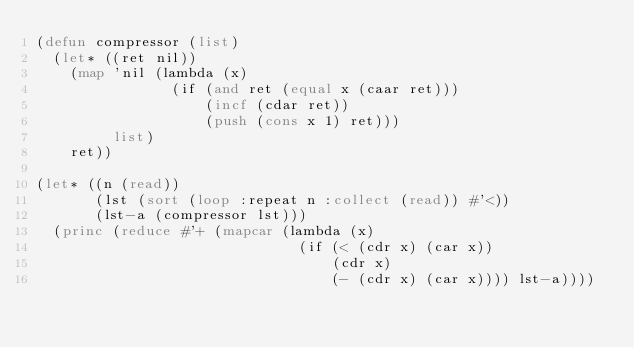<code> <loc_0><loc_0><loc_500><loc_500><_Lisp_>(defun compressor (list)
  (let* ((ret nil))
    (map 'nil (lambda (x)
                (if (and ret (equal x (caar ret)))
                    (incf (cdar ret))
                    (push (cons x 1) ret)))
         list)
    ret))

(let* ((n (read))
       (lst (sort (loop :repeat n :collect (read)) #'<))
       (lst-a (compressor lst)))
  (princ (reduce #'+ (mapcar (lambda (x)
                               (if (< (cdr x) (car x))
                                   (cdr x)
                                   (- (cdr x) (car x)))) lst-a))))
</code> 